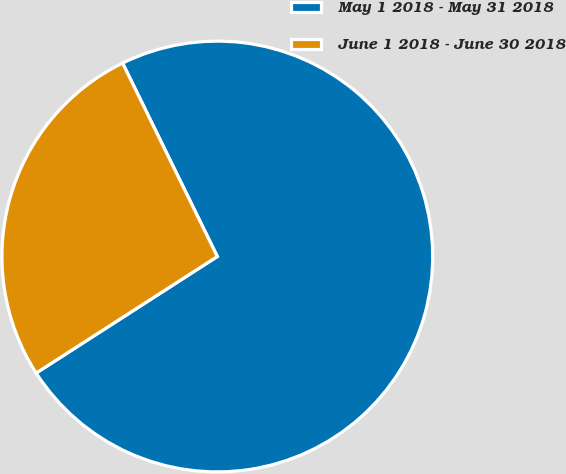Convert chart. <chart><loc_0><loc_0><loc_500><loc_500><pie_chart><fcel>May 1 2018 - May 31 2018<fcel>June 1 2018 - June 30 2018<nl><fcel>73.15%<fcel>26.85%<nl></chart> 